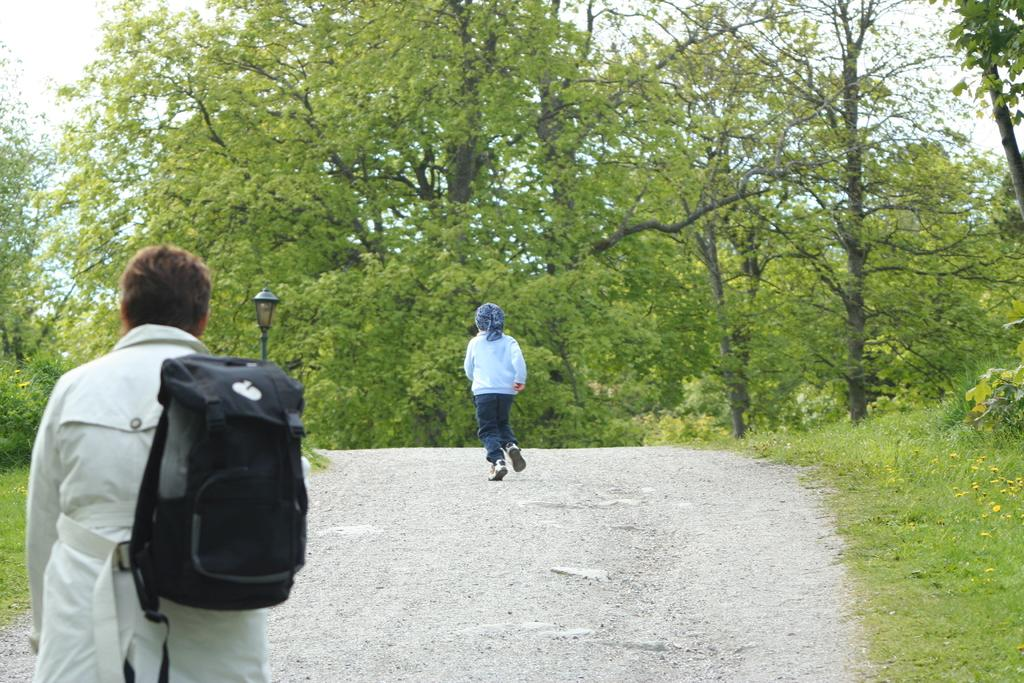What is the person in the image carrying on their shoulders? The person is holding a bag on their shoulders. What is the person doing in the image? The person is walking on the road. What is the child in the image doing? The child is running. What can be seen in the background of the image? Trees and the sky are visible in the background. What religion is the person practicing in the image? There is no indication of any religious practice in the image. Can you see a squirrel running alongside the child in the image? There is no squirrel present in the image. 